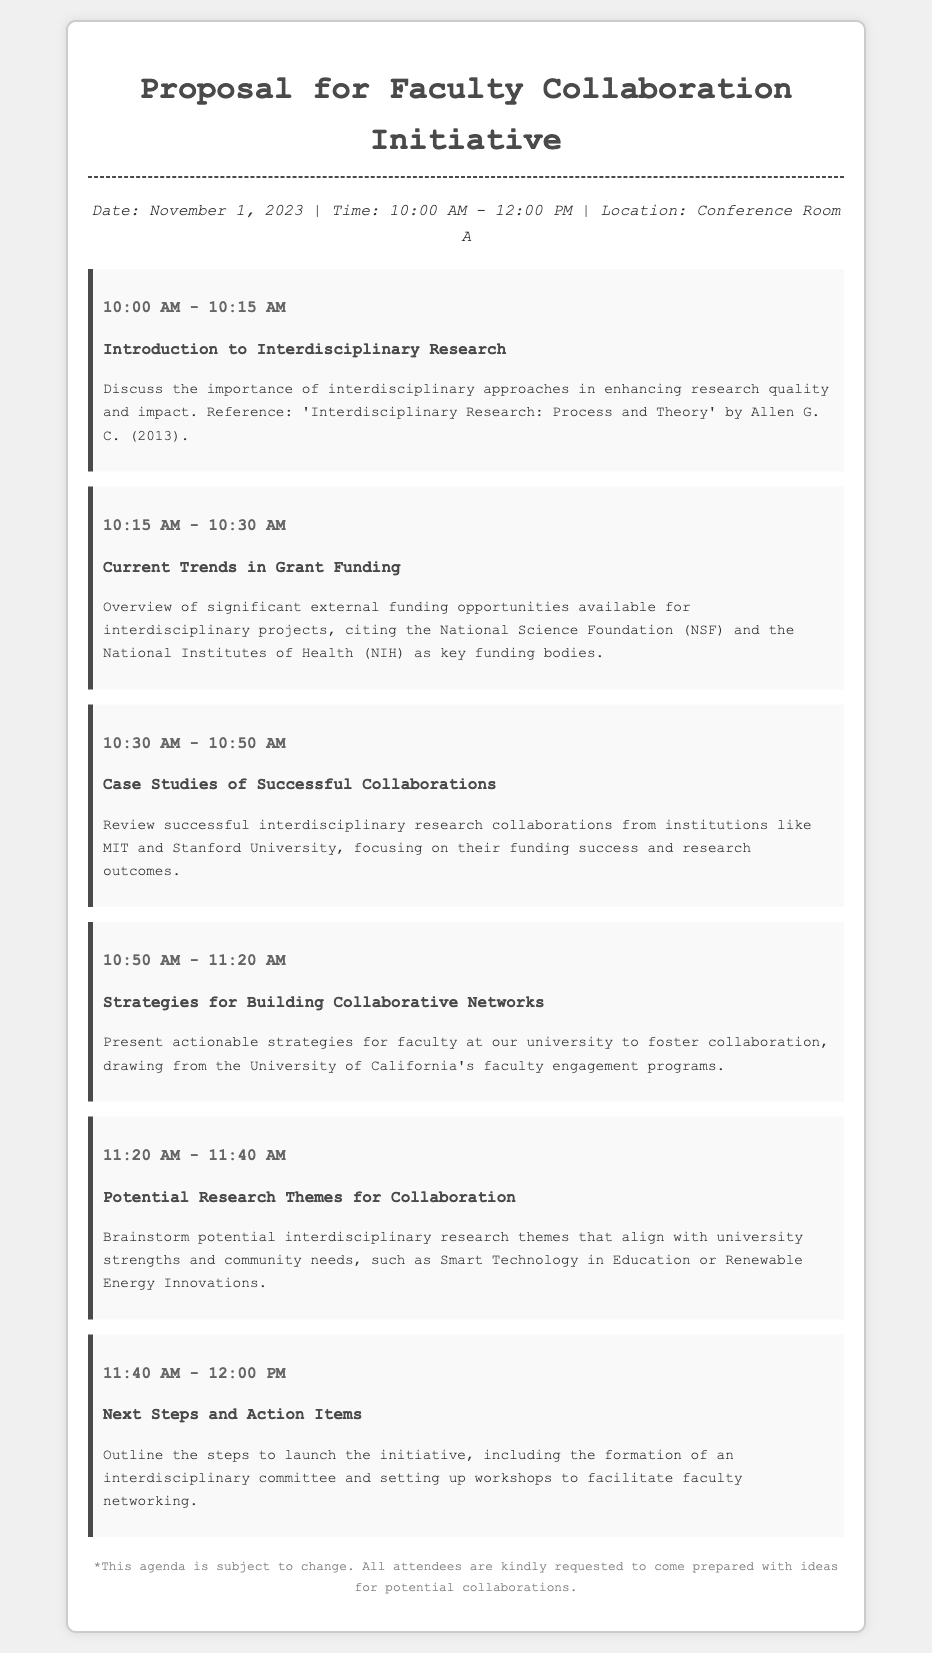What is the date of the meeting? The date of the meeting is explicitly mentioned in the document as November 1, 2023.
Answer: November 1, 2023 What time does the meeting start? The meeting start time is indicated in the header information of the document.
Answer: 10:00 AM Who is one of the key funding bodies mentioned for interdisciplinary projects? The document provides details of specific external funding bodies, including the National Science Foundation.
Answer: National Science Foundation What is the main topic discussed during the 10:30 AM session? The agenda details the specific topics for each time slot, and at 10:30 AM, the topic is case studies.
Answer: Case Studies of Successful Collaborations Which institution's faculty engagement programs are referenced for building collaborative networks? The document mentions specific institutions and their programs related to collaboration, highlighting the University of California.
Answer: University of California How long is the session on Potential Research Themes for Collaboration? The duration of this session is specified in the agenda, showing the time allocated for it.
Answer: 20 minutes What is one example of a potential research theme mentioned? The document includes examples of interdisciplinary research themes, such as Smart Technology in Education.
Answer: Smart Technology in Education What is one action item discussed during the last agenda item? The last agenda item outlines steps to launch the initiative, specifically mentioning the formation of a committee.
Answer: Formation of an interdisciplinary committee 